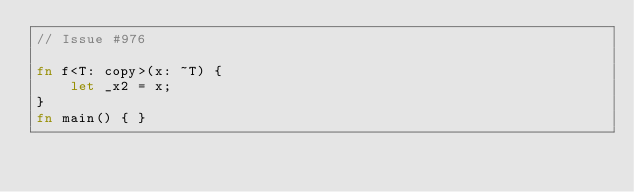<code> <loc_0><loc_0><loc_500><loc_500><_Rust_>// Issue #976

fn f<T: copy>(x: ~T) {
    let _x2 = x;
}
fn main() { }
</code> 